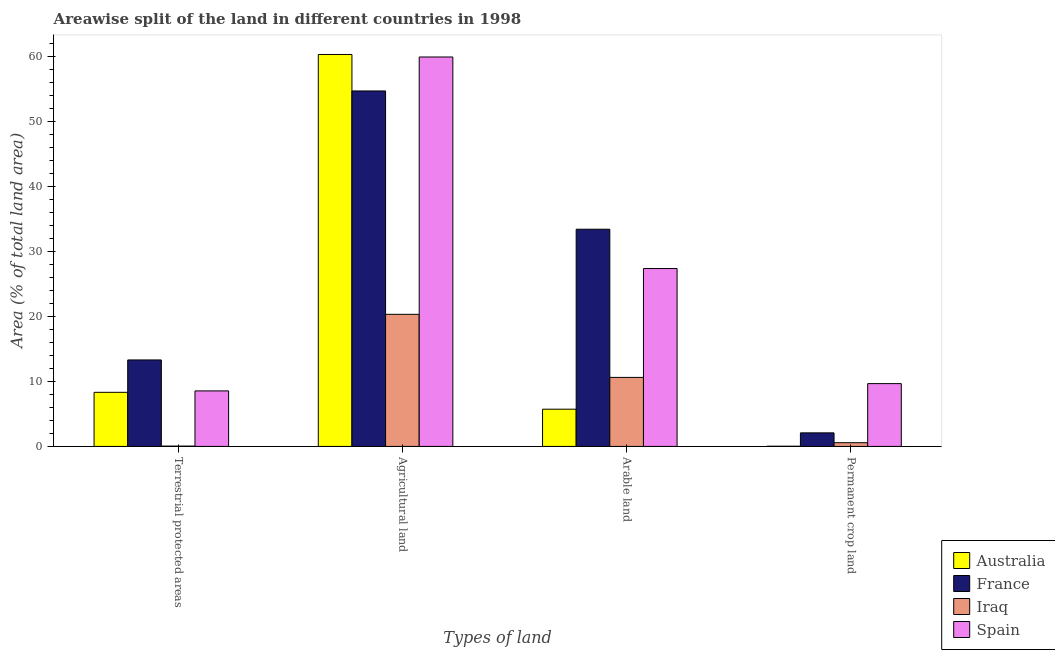Are the number of bars on each tick of the X-axis equal?
Offer a terse response. Yes. How many bars are there on the 4th tick from the left?
Your response must be concise. 4. How many bars are there on the 2nd tick from the right?
Provide a short and direct response. 4. What is the label of the 3rd group of bars from the left?
Offer a very short reply. Arable land. What is the percentage of land under terrestrial protection in Spain?
Your answer should be very brief. 8.55. Across all countries, what is the maximum percentage of area under agricultural land?
Provide a short and direct response. 60.37. Across all countries, what is the minimum percentage of area under arable land?
Provide a short and direct response. 5.73. In which country was the percentage of area under arable land maximum?
Your response must be concise. France. In which country was the percentage of area under arable land minimum?
Your answer should be compact. Australia. What is the total percentage of area under permanent crop land in the graph?
Make the answer very short. 12.37. What is the difference between the percentage of area under agricultural land in France and that in Australia?
Make the answer very short. -5.62. What is the difference between the percentage of area under agricultural land in Spain and the percentage of land under terrestrial protection in Australia?
Offer a very short reply. 51.65. What is the average percentage of area under arable land per country?
Your response must be concise. 19.3. What is the difference between the percentage of area under permanent crop land and percentage of area under arable land in Iraq?
Provide a short and direct response. -10.06. In how many countries, is the percentage of land under terrestrial protection greater than 60 %?
Keep it short and to the point. 0. What is the ratio of the percentage of area under permanent crop land in France to that in Iraq?
Provide a short and direct response. 3.66. Is the difference between the percentage of area under permanent crop land in France and Iraq greater than the difference between the percentage of land under terrestrial protection in France and Iraq?
Offer a very short reply. No. What is the difference between the highest and the second highest percentage of area under permanent crop land?
Ensure brevity in your answer.  7.59. What is the difference between the highest and the lowest percentage of area under arable land?
Your answer should be compact. 27.72. In how many countries, is the percentage of area under permanent crop land greater than the average percentage of area under permanent crop land taken over all countries?
Your response must be concise. 1. Is it the case that in every country, the sum of the percentage of land under terrestrial protection and percentage of area under permanent crop land is greater than the sum of percentage of area under arable land and percentage of area under agricultural land?
Ensure brevity in your answer.  No. What does the 2nd bar from the right in Terrestrial protected areas represents?
Offer a terse response. Iraq. Are all the bars in the graph horizontal?
Ensure brevity in your answer.  No. What is the difference between two consecutive major ticks on the Y-axis?
Provide a succinct answer. 10. Are the values on the major ticks of Y-axis written in scientific E-notation?
Make the answer very short. No. Does the graph contain any zero values?
Offer a terse response. No. Does the graph contain grids?
Offer a very short reply. No. Where does the legend appear in the graph?
Keep it short and to the point. Bottom right. How are the legend labels stacked?
Provide a short and direct response. Vertical. What is the title of the graph?
Make the answer very short. Areawise split of the land in different countries in 1998. What is the label or title of the X-axis?
Provide a short and direct response. Types of land. What is the label or title of the Y-axis?
Your answer should be compact. Area (% of total land area). What is the Area (% of total land area) in Australia in Terrestrial protected areas?
Give a very brief answer. 8.33. What is the Area (% of total land area) of France in Terrestrial protected areas?
Provide a succinct answer. 13.32. What is the Area (% of total land area) in Iraq in Terrestrial protected areas?
Provide a short and direct response. 0.05. What is the Area (% of total land area) in Spain in Terrestrial protected areas?
Provide a succinct answer. 8.55. What is the Area (% of total land area) in Australia in Agricultural land?
Keep it short and to the point. 60.37. What is the Area (% of total land area) in France in Agricultural land?
Offer a very short reply. 54.75. What is the Area (% of total land area) in Iraq in Agricultural land?
Ensure brevity in your answer.  20.35. What is the Area (% of total land area) in Spain in Agricultural land?
Give a very brief answer. 59.98. What is the Area (% of total land area) in Australia in Arable land?
Your answer should be very brief. 5.73. What is the Area (% of total land area) of France in Arable land?
Your response must be concise. 33.45. What is the Area (% of total land area) in Iraq in Arable land?
Offer a very short reply. 10.63. What is the Area (% of total land area) of Spain in Arable land?
Make the answer very short. 27.4. What is the Area (% of total land area) of Australia in Permanent crop land?
Your answer should be very brief. 0.03. What is the Area (% of total land area) of France in Permanent crop land?
Offer a terse response. 2.09. What is the Area (% of total land area) in Iraq in Permanent crop land?
Give a very brief answer. 0.57. What is the Area (% of total land area) of Spain in Permanent crop land?
Keep it short and to the point. 9.67. Across all Types of land, what is the maximum Area (% of total land area) of Australia?
Give a very brief answer. 60.37. Across all Types of land, what is the maximum Area (% of total land area) of France?
Your answer should be very brief. 54.75. Across all Types of land, what is the maximum Area (% of total land area) of Iraq?
Your response must be concise. 20.35. Across all Types of land, what is the maximum Area (% of total land area) in Spain?
Offer a very short reply. 59.98. Across all Types of land, what is the minimum Area (% of total land area) in Australia?
Ensure brevity in your answer.  0.03. Across all Types of land, what is the minimum Area (% of total land area) of France?
Offer a terse response. 2.09. Across all Types of land, what is the minimum Area (% of total land area) in Iraq?
Keep it short and to the point. 0.05. Across all Types of land, what is the minimum Area (% of total land area) of Spain?
Offer a very short reply. 8.55. What is the total Area (% of total land area) of Australia in the graph?
Keep it short and to the point. 74.47. What is the total Area (% of total land area) in France in the graph?
Your answer should be very brief. 103.61. What is the total Area (% of total land area) in Iraq in the graph?
Provide a succinct answer. 31.6. What is the total Area (% of total land area) in Spain in the graph?
Your response must be concise. 105.61. What is the difference between the Area (% of total land area) of Australia in Terrestrial protected areas and that in Agricultural land?
Provide a short and direct response. -52.04. What is the difference between the Area (% of total land area) in France in Terrestrial protected areas and that in Agricultural land?
Your answer should be compact. -41.43. What is the difference between the Area (% of total land area) in Iraq in Terrestrial protected areas and that in Agricultural land?
Your response must be concise. -20.3. What is the difference between the Area (% of total land area) of Spain in Terrestrial protected areas and that in Agricultural land?
Provide a short and direct response. -51.43. What is the difference between the Area (% of total land area) of Australia in Terrestrial protected areas and that in Arable land?
Offer a terse response. 2.6. What is the difference between the Area (% of total land area) of France in Terrestrial protected areas and that in Arable land?
Your answer should be very brief. -20.13. What is the difference between the Area (% of total land area) of Iraq in Terrestrial protected areas and that in Arable land?
Keep it short and to the point. -10.58. What is the difference between the Area (% of total land area) of Spain in Terrestrial protected areas and that in Arable land?
Make the answer very short. -18.84. What is the difference between the Area (% of total land area) in Australia in Terrestrial protected areas and that in Permanent crop land?
Your answer should be very brief. 8.3. What is the difference between the Area (% of total land area) of France in Terrestrial protected areas and that in Permanent crop land?
Offer a terse response. 11.23. What is the difference between the Area (% of total land area) of Iraq in Terrestrial protected areas and that in Permanent crop land?
Keep it short and to the point. -0.52. What is the difference between the Area (% of total land area) in Spain in Terrestrial protected areas and that in Permanent crop land?
Make the answer very short. -1.12. What is the difference between the Area (% of total land area) in Australia in Agricultural land and that in Arable land?
Give a very brief answer. 54.64. What is the difference between the Area (% of total land area) of France in Agricultural land and that in Arable land?
Your response must be concise. 21.3. What is the difference between the Area (% of total land area) in Iraq in Agricultural land and that in Arable land?
Your answer should be compact. 9.72. What is the difference between the Area (% of total land area) of Spain in Agricultural land and that in Arable land?
Ensure brevity in your answer.  32.58. What is the difference between the Area (% of total land area) of Australia in Agricultural land and that in Permanent crop land?
Ensure brevity in your answer.  60.34. What is the difference between the Area (% of total land area) in France in Agricultural land and that in Permanent crop land?
Make the answer very short. 52.66. What is the difference between the Area (% of total land area) of Iraq in Agricultural land and that in Permanent crop land?
Provide a short and direct response. 19.78. What is the difference between the Area (% of total land area) of Spain in Agricultural land and that in Permanent crop land?
Your answer should be compact. 50.31. What is the difference between the Area (% of total land area) in Australia in Arable land and that in Permanent crop land?
Provide a succinct answer. 5.7. What is the difference between the Area (% of total land area) in France in Arable land and that in Permanent crop land?
Keep it short and to the point. 31.36. What is the difference between the Area (% of total land area) of Iraq in Arable land and that in Permanent crop land?
Offer a very short reply. 10.06. What is the difference between the Area (% of total land area) in Spain in Arable land and that in Permanent crop land?
Your answer should be very brief. 17.72. What is the difference between the Area (% of total land area) of Australia in Terrestrial protected areas and the Area (% of total land area) of France in Agricultural land?
Your response must be concise. -46.42. What is the difference between the Area (% of total land area) of Australia in Terrestrial protected areas and the Area (% of total land area) of Iraq in Agricultural land?
Provide a short and direct response. -12.02. What is the difference between the Area (% of total land area) in Australia in Terrestrial protected areas and the Area (% of total land area) in Spain in Agricultural land?
Make the answer very short. -51.65. What is the difference between the Area (% of total land area) in France in Terrestrial protected areas and the Area (% of total land area) in Iraq in Agricultural land?
Your answer should be compact. -7.03. What is the difference between the Area (% of total land area) of France in Terrestrial protected areas and the Area (% of total land area) of Spain in Agricultural land?
Provide a succinct answer. -46.66. What is the difference between the Area (% of total land area) of Iraq in Terrestrial protected areas and the Area (% of total land area) of Spain in Agricultural land?
Your answer should be very brief. -59.93. What is the difference between the Area (% of total land area) of Australia in Terrestrial protected areas and the Area (% of total land area) of France in Arable land?
Your response must be concise. -25.12. What is the difference between the Area (% of total land area) of Australia in Terrestrial protected areas and the Area (% of total land area) of Iraq in Arable land?
Keep it short and to the point. -2.3. What is the difference between the Area (% of total land area) in Australia in Terrestrial protected areas and the Area (% of total land area) in Spain in Arable land?
Make the answer very short. -19.07. What is the difference between the Area (% of total land area) of France in Terrestrial protected areas and the Area (% of total land area) of Iraq in Arable land?
Your answer should be compact. 2.69. What is the difference between the Area (% of total land area) in France in Terrestrial protected areas and the Area (% of total land area) in Spain in Arable land?
Provide a succinct answer. -14.08. What is the difference between the Area (% of total land area) in Iraq in Terrestrial protected areas and the Area (% of total land area) in Spain in Arable land?
Your answer should be very brief. -27.35. What is the difference between the Area (% of total land area) in Australia in Terrestrial protected areas and the Area (% of total land area) in France in Permanent crop land?
Your answer should be very brief. 6.24. What is the difference between the Area (% of total land area) in Australia in Terrestrial protected areas and the Area (% of total land area) in Iraq in Permanent crop land?
Make the answer very short. 7.76. What is the difference between the Area (% of total land area) in Australia in Terrestrial protected areas and the Area (% of total land area) in Spain in Permanent crop land?
Make the answer very short. -1.34. What is the difference between the Area (% of total land area) of France in Terrestrial protected areas and the Area (% of total land area) of Iraq in Permanent crop land?
Provide a short and direct response. 12.75. What is the difference between the Area (% of total land area) in France in Terrestrial protected areas and the Area (% of total land area) in Spain in Permanent crop land?
Your answer should be compact. 3.65. What is the difference between the Area (% of total land area) in Iraq in Terrestrial protected areas and the Area (% of total land area) in Spain in Permanent crop land?
Ensure brevity in your answer.  -9.62. What is the difference between the Area (% of total land area) in Australia in Agricultural land and the Area (% of total land area) in France in Arable land?
Your answer should be compact. 26.92. What is the difference between the Area (% of total land area) of Australia in Agricultural land and the Area (% of total land area) of Iraq in Arable land?
Provide a succinct answer. 49.74. What is the difference between the Area (% of total land area) in Australia in Agricultural land and the Area (% of total land area) in Spain in Arable land?
Offer a terse response. 32.97. What is the difference between the Area (% of total land area) of France in Agricultural land and the Area (% of total land area) of Iraq in Arable land?
Your answer should be compact. 44.12. What is the difference between the Area (% of total land area) of France in Agricultural land and the Area (% of total land area) of Spain in Arable land?
Make the answer very short. 27.35. What is the difference between the Area (% of total land area) of Iraq in Agricultural land and the Area (% of total land area) of Spain in Arable land?
Your answer should be very brief. -7.05. What is the difference between the Area (% of total land area) in Australia in Agricultural land and the Area (% of total land area) in France in Permanent crop land?
Provide a short and direct response. 58.28. What is the difference between the Area (% of total land area) in Australia in Agricultural land and the Area (% of total land area) in Iraq in Permanent crop land?
Your answer should be very brief. 59.8. What is the difference between the Area (% of total land area) of Australia in Agricultural land and the Area (% of total land area) of Spain in Permanent crop land?
Offer a terse response. 50.7. What is the difference between the Area (% of total land area) of France in Agricultural land and the Area (% of total land area) of Iraq in Permanent crop land?
Your response must be concise. 54.18. What is the difference between the Area (% of total land area) in France in Agricultural land and the Area (% of total land area) in Spain in Permanent crop land?
Your response must be concise. 45.08. What is the difference between the Area (% of total land area) of Iraq in Agricultural land and the Area (% of total land area) of Spain in Permanent crop land?
Offer a terse response. 10.67. What is the difference between the Area (% of total land area) in Australia in Arable land and the Area (% of total land area) in France in Permanent crop land?
Your answer should be compact. 3.65. What is the difference between the Area (% of total land area) of Australia in Arable land and the Area (% of total land area) of Iraq in Permanent crop land?
Offer a very short reply. 5.16. What is the difference between the Area (% of total land area) in Australia in Arable land and the Area (% of total land area) in Spain in Permanent crop land?
Ensure brevity in your answer.  -3.94. What is the difference between the Area (% of total land area) of France in Arable land and the Area (% of total land area) of Iraq in Permanent crop land?
Offer a terse response. 32.88. What is the difference between the Area (% of total land area) in France in Arable land and the Area (% of total land area) in Spain in Permanent crop land?
Your answer should be very brief. 23.78. What is the difference between the Area (% of total land area) in Iraq in Arable land and the Area (% of total land area) in Spain in Permanent crop land?
Make the answer very short. 0.96. What is the average Area (% of total land area) of Australia per Types of land?
Offer a very short reply. 18.62. What is the average Area (% of total land area) of France per Types of land?
Your response must be concise. 25.9. What is the average Area (% of total land area) in Iraq per Types of land?
Provide a succinct answer. 7.9. What is the average Area (% of total land area) in Spain per Types of land?
Your answer should be compact. 26.4. What is the difference between the Area (% of total land area) of Australia and Area (% of total land area) of France in Terrestrial protected areas?
Offer a terse response. -4.99. What is the difference between the Area (% of total land area) of Australia and Area (% of total land area) of Iraq in Terrestrial protected areas?
Provide a short and direct response. 8.28. What is the difference between the Area (% of total land area) of Australia and Area (% of total land area) of Spain in Terrestrial protected areas?
Your answer should be very brief. -0.22. What is the difference between the Area (% of total land area) in France and Area (% of total land area) in Iraq in Terrestrial protected areas?
Your answer should be compact. 13.27. What is the difference between the Area (% of total land area) of France and Area (% of total land area) of Spain in Terrestrial protected areas?
Your answer should be compact. 4.77. What is the difference between the Area (% of total land area) in Iraq and Area (% of total land area) in Spain in Terrestrial protected areas?
Your answer should be compact. -8.5. What is the difference between the Area (% of total land area) of Australia and Area (% of total land area) of France in Agricultural land?
Provide a short and direct response. 5.62. What is the difference between the Area (% of total land area) of Australia and Area (% of total land area) of Iraq in Agricultural land?
Give a very brief answer. 40.02. What is the difference between the Area (% of total land area) in Australia and Area (% of total land area) in Spain in Agricultural land?
Your answer should be very brief. 0.39. What is the difference between the Area (% of total land area) in France and Area (% of total land area) in Iraq in Agricultural land?
Ensure brevity in your answer.  34.4. What is the difference between the Area (% of total land area) in France and Area (% of total land area) in Spain in Agricultural land?
Provide a short and direct response. -5.23. What is the difference between the Area (% of total land area) in Iraq and Area (% of total land area) in Spain in Agricultural land?
Offer a very short reply. -39.63. What is the difference between the Area (% of total land area) in Australia and Area (% of total land area) in France in Arable land?
Give a very brief answer. -27.72. What is the difference between the Area (% of total land area) in Australia and Area (% of total land area) in Iraq in Arable land?
Make the answer very short. -4.9. What is the difference between the Area (% of total land area) in Australia and Area (% of total land area) in Spain in Arable land?
Your response must be concise. -21.66. What is the difference between the Area (% of total land area) of France and Area (% of total land area) of Iraq in Arable land?
Ensure brevity in your answer.  22.82. What is the difference between the Area (% of total land area) of France and Area (% of total land area) of Spain in Arable land?
Keep it short and to the point. 6.05. What is the difference between the Area (% of total land area) of Iraq and Area (% of total land area) of Spain in Arable land?
Your response must be concise. -16.77. What is the difference between the Area (% of total land area) of Australia and Area (% of total land area) of France in Permanent crop land?
Provide a succinct answer. -2.06. What is the difference between the Area (% of total land area) in Australia and Area (% of total land area) in Iraq in Permanent crop land?
Offer a very short reply. -0.54. What is the difference between the Area (% of total land area) in Australia and Area (% of total land area) in Spain in Permanent crop land?
Ensure brevity in your answer.  -9.64. What is the difference between the Area (% of total land area) of France and Area (% of total land area) of Iraq in Permanent crop land?
Offer a very short reply. 1.52. What is the difference between the Area (% of total land area) in France and Area (% of total land area) in Spain in Permanent crop land?
Provide a short and direct response. -7.59. What is the difference between the Area (% of total land area) of Iraq and Area (% of total land area) of Spain in Permanent crop land?
Your answer should be very brief. -9.1. What is the ratio of the Area (% of total land area) in Australia in Terrestrial protected areas to that in Agricultural land?
Make the answer very short. 0.14. What is the ratio of the Area (% of total land area) in France in Terrestrial protected areas to that in Agricultural land?
Offer a terse response. 0.24. What is the ratio of the Area (% of total land area) of Iraq in Terrestrial protected areas to that in Agricultural land?
Your answer should be compact. 0. What is the ratio of the Area (% of total land area) in Spain in Terrestrial protected areas to that in Agricultural land?
Provide a succinct answer. 0.14. What is the ratio of the Area (% of total land area) in Australia in Terrestrial protected areas to that in Arable land?
Offer a very short reply. 1.45. What is the ratio of the Area (% of total land area) of France in Terrestrial protected areas to that in Arable land?
Your answer should be compact. 0.4. What is the ratio of the Area (% of total land area) in Iraq in Terrestrial protected areas to that in Arable land?
Your answer should be compact. 0. What is the ratio of the Area (% of total land area) in Spain in Terrestrial protected areas to that in Arable land?
Offer a very short reply. 0.31. What is the ratio of the Area (% of total land area) of Australia in Terrestrial protected areas to that in Permanent crop land?
Provide a short and direct response. 261.31. What is the ratio of the Area (% of total land area) in France in Terrestrial protected areas to that in Permanent crop land?
Make the answer very short. 6.38. What is the ratio of the Area (% of total land area) in Iraq in Terrestrial protected areas to that in Permanent crop land?
Your answer should be compact. 0.09. What is the ratio of the Area (% of total land area) of Spain in Terrestrial protected areas to that in Permanent crop land?
Your answer should be very brief. 0.88. What is the ratio of the Area (% of total land area) in Australia in Agricultural land to that in Arable land?
Make the answer very short. 10.53. What is the ratio of the Area (% of total land area) in France in Agricultural land to that in Arable land?
Provide a short and direct response. 1.64. What is the ratio of the Area (% of total land area) of Iraq in Agricultural land to that in Arable land?
Keep it short and to the point. 1.91. What is the ratio of the Area (% of total land area) of Spain in Agricultural land to that in Arable land?
Provide a succinct answer. 2.19. What is the ratio of the Area (% of total land area) in Australia in Agricultural land to that in Permanent crop land?
Provide a succinct answer. 1893. What is the ratio of the Area (% of total land area) of France in Agricultural land to that in Permanent crop land?
Provide a succinct answer. 26.21. What is the ratio of the Area (% of total land area) of Iraq in Agricultural land to that in Permanent crop land?
Ensure brevity in your answer.  35.6. What is the ratio of the Area (% of total land area) of Spain in Agricultural land to that in Permanent crop land?
Your answer should be very brief. 6.2. What is the ratio of the Area (% of total land area) in Australia in Arable land to that in Permanent crop land?
Ensure brevity in your answer.  179.82. What is the ratio of the Area (% of total land area) of France in Arable land to that in Permanent crop land?
Your response must be concise. 16.01. What is the ratio of the Area (% of total land area) of Iraq in Arable land to that in Permanent crop land?
Offer a very short reply. 18.6. What is the ratio of the Area (% of total land area) of Spain in Arable land to that in Permanent crop land?
Your answer should be compact. 2.83. What is the difference between the highest and the second highest Area (% of total land area) of Australia?
Ensure brevity in your answer.  52.04. What is the difference between the highest and the second highest Area (% of total land area) in France?
Provide a short and direct response. 21.3. What is the difference between the highest and the second highest Area (% of total land area) in Iraq?
Your response must be concise. 9.72. What is the difference between the highest and the second highest Area (% of total land area) in Spain?
Make the answer very short. 32.58. What is the difference between the highest and the lowest Area (% of total land area) of Australia?
Give a very brief answer. 60.34. What is the difference between the highest and the lowest Area (% of total land area) in France?
Offer a terse response. 52.66. What is the difference between the highest and the lowest Area (% of total land area) of Iraq?
Make the answer very short. 20.3. What is the difference between the highest and the lowest Area (% of total land area) of Spain?
Your answer should be compact. 51.43. 